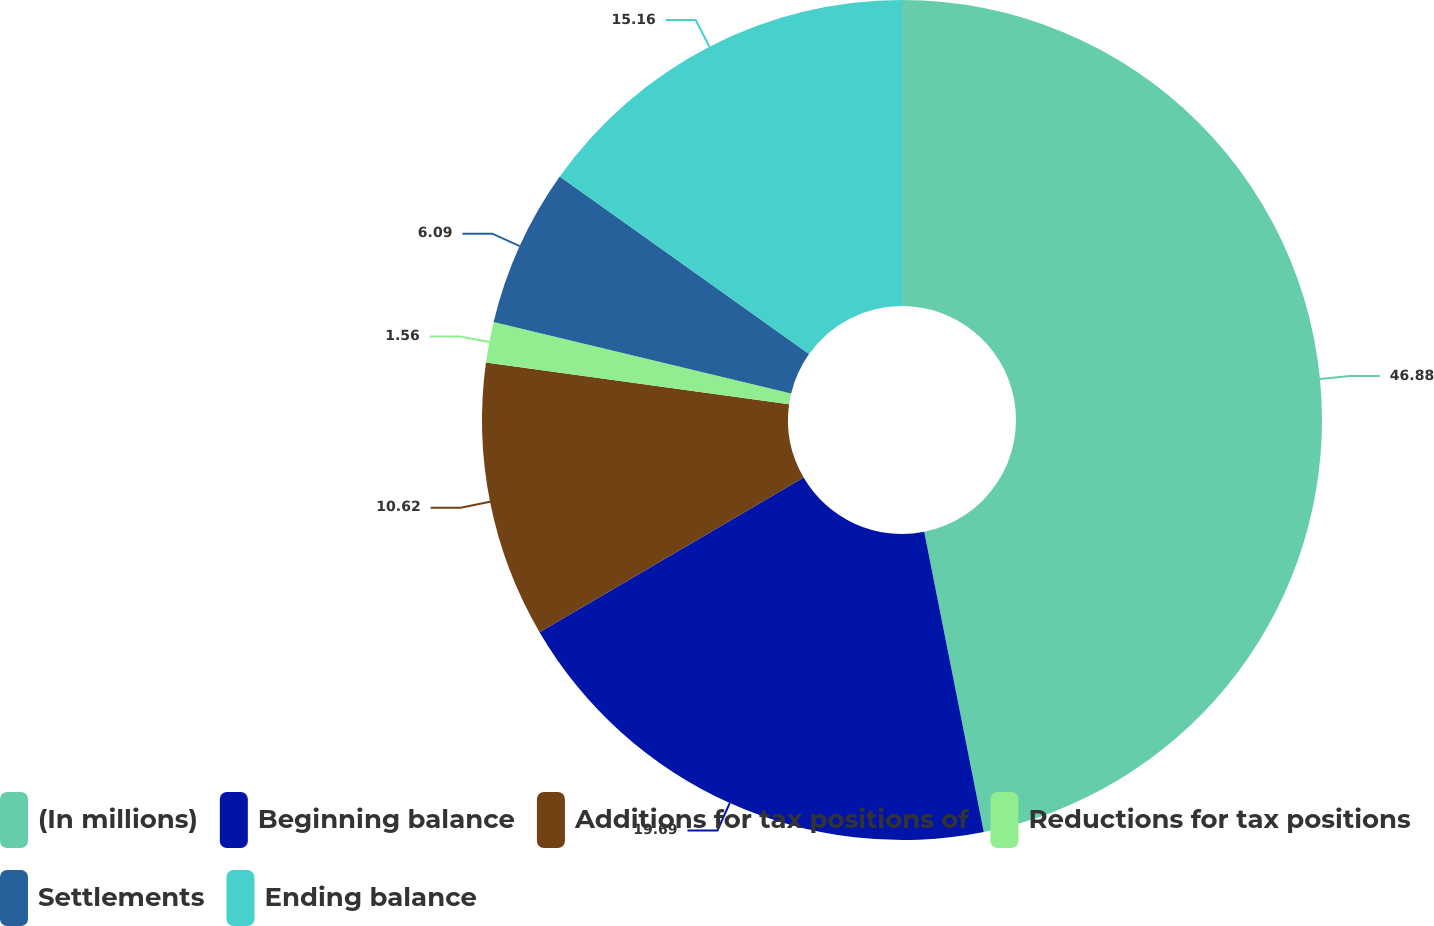<chart> <loc_0><loc_0><loc_500><loc_500><pie_chart><fcel>(In millions)<fcel>Beginning balance<fcel>Additions for tax positions of<fcel>Reductions for tax positions<fcel>Settlements<fcel>Ending balance<nl><fcel>46.88%<fcel>19.69%<fcel>10.62%<fcel>1.56%<fcel>6.09%<fcel>15.16%<nl></chart> 